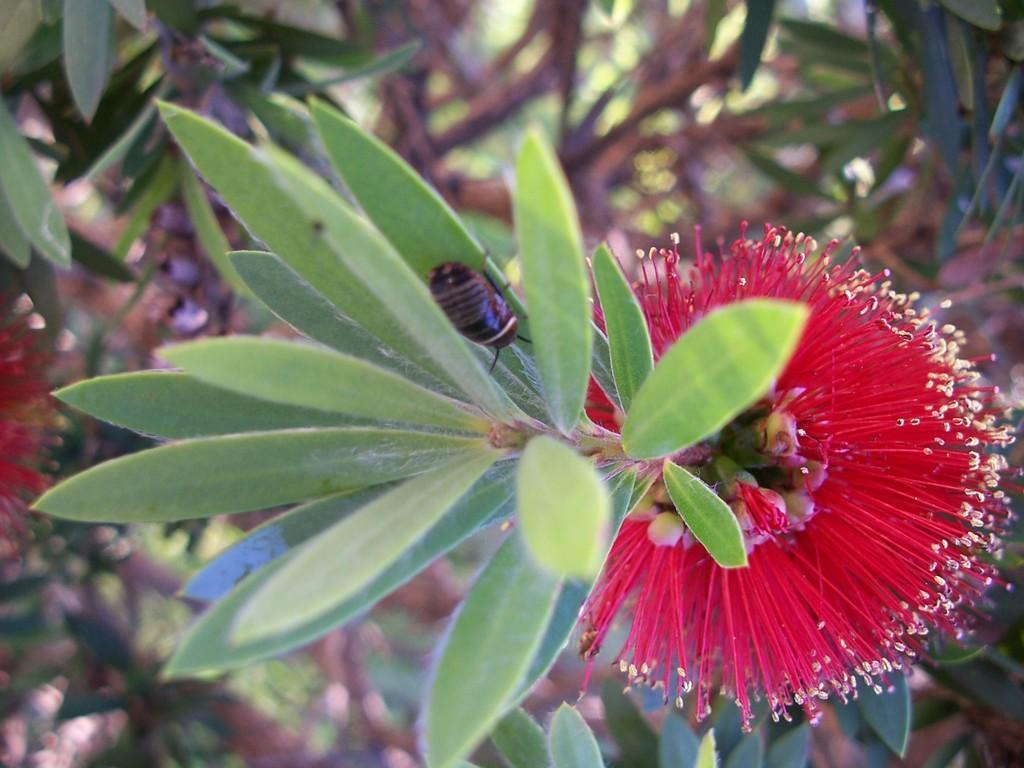How would you summarize this image in a sentence or two? In this image I can see green colour leaves, a red colour flower and a black colour insect over here. 